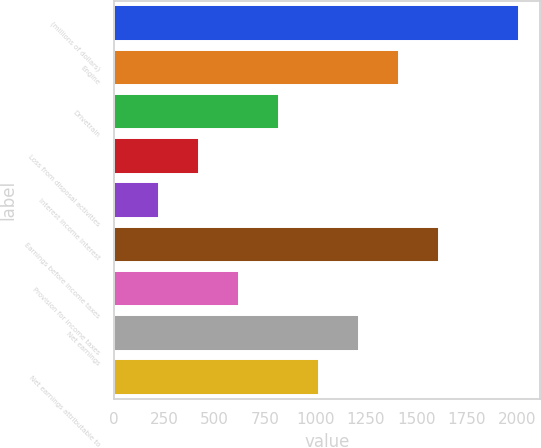Convert chart to OTSL. <chart><loc_0><loc_0><loc_500><loc_500><bar_chart><fcel>(millions of dollars)<fcel>Engine<fcel>Drivetrain<fcel>Loss from disposal activities<fcel>Interest income Interest<fcel>Earnings before income taxes<fcel>Provision for income taxes<fcel>Net earnings<fcel>Net earnings attributable to<nl><fcel>2013<fcel>1417.11<fcel>821.22<fcel>423.96<fcel>225.33<fcel>1615.74<fcel>622.59<fcel>1218.48<fcel>1019.85<nl></chart> 